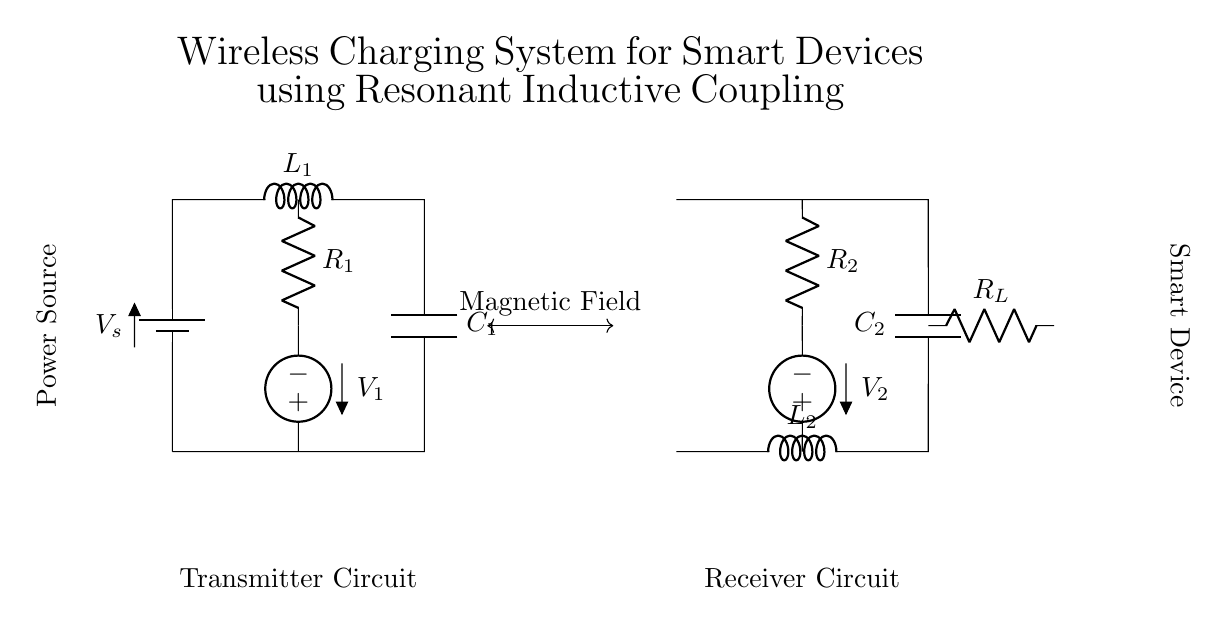What is the first component in the transmitter circuit? The first component in the transmitter circuit is a battery, which serves as the power source for the circuit. It is labeled as V_s in the diagram.
Answer: Battery What is the load resistance value? In the circuit diagram, the load resistance is labeled as R_L, and while the exact value isn't specified, it represents the load connected to the receiver.
Answer: R_L How many inductors are present in the circuit? There are two inductors in the circuit, labeled as L_1 in the transmitter side and L_2 in the receiver side, indicating their role in inductive coupling.
Answer: Two What is the main function of the magnetic field indicated in the diagram? The magnetic field, represented by the double-headed arrow between the transmitter and receiver, signifies the means by which power is transferred wirelessly through resonant inductive coupling.
Answer: Power transfer Which component connects to the voltage source in the receiver circuit? The voltage source in the receiver circuit connects to the resistor R_2, which allows for current flow to the rest of the receiver circuit.
Answer: R_2 What type of coupling is used in this wireless charging system? The coupling used in this wireless charging system is resonant inductive coupling, which enables efficient power transfer over short distances without physical connections.
Answer: Resonant inductive coupling What is typically the role of the capacitor in resonant circuits? The capacitor's role in resonant circuits is to store and release energy, thus helping to create resonant oscillation with the inductor to facilitate efficient power transfer in the system.
Answer: Energy storage 